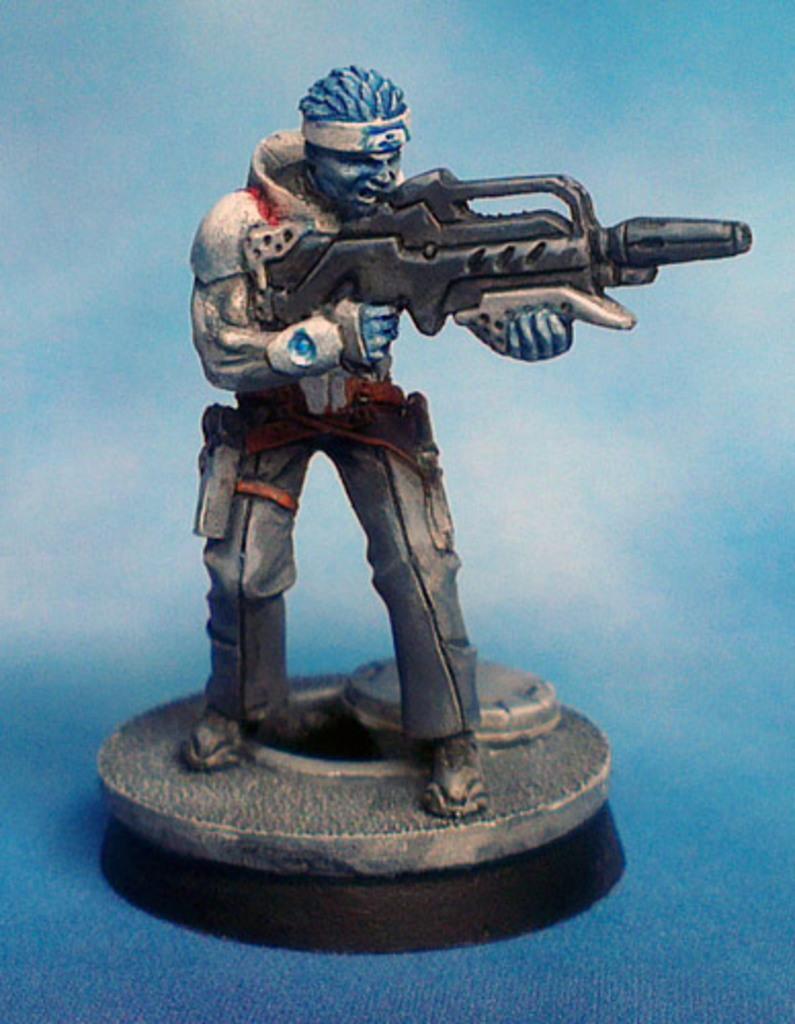Can you describe this image briefly? In this picture we can see a toy of a man holding a gun with his hands and standing on a platform. 